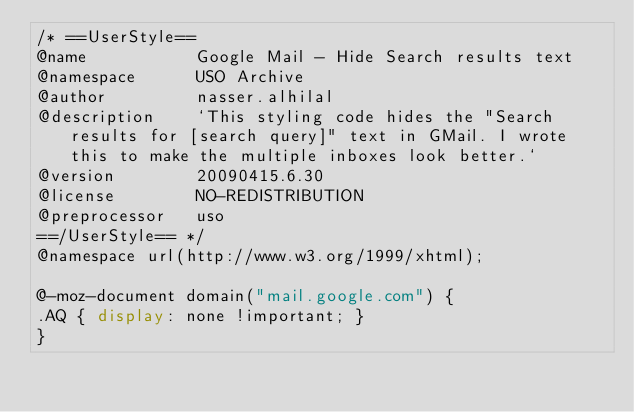Convert code to text. <code><loc_0><loc_0><loc_500><loc_500><_CSS_>/* ==UserStyle==
@name           Google Mail - Hide Search results text
@namespace      USO Archive
@author         nasser.alhilal
@description    `This styling code hides the "Search results for [search query]" text in GMail. I wrote this to make the multiple inboxes look better.`
@version        20090415.6.30
@license        NO-REDISTRIBUTION
@preprocessor   uso
==/UserStyle== */
@namespace url(http://www.w3.org/1999/xhtml);

@-moz-document domain("mail.google.com") {
.AQ { display: none !important; }
}</code> 